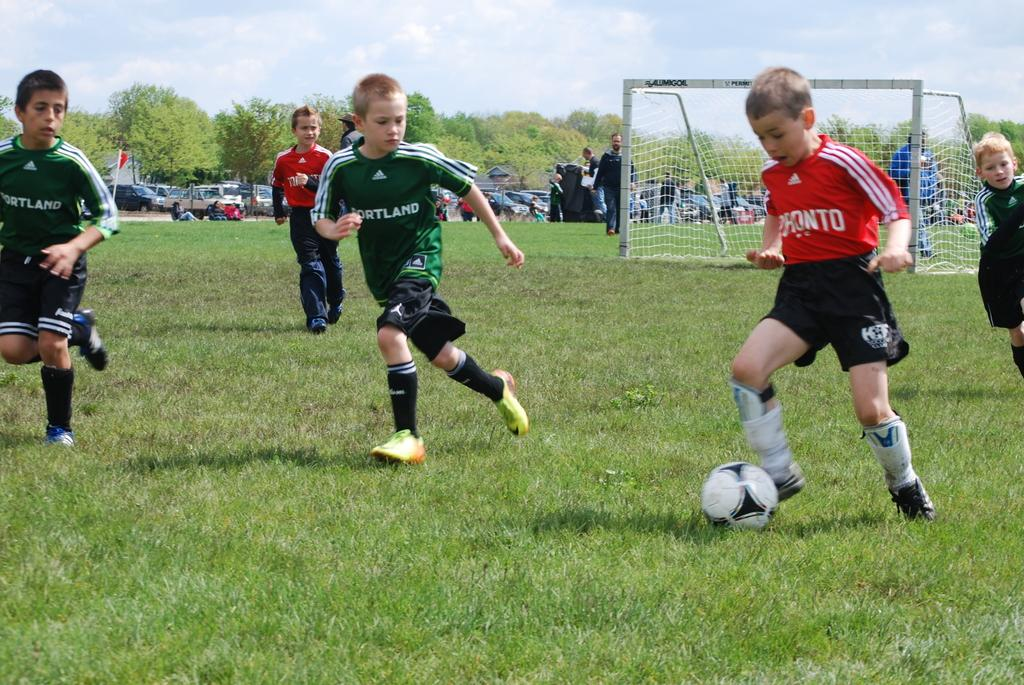Provide a one-sentence caption for the provided image. A box on team Portland chases an opposing teams player as he kicks the soccer ball down the field. 